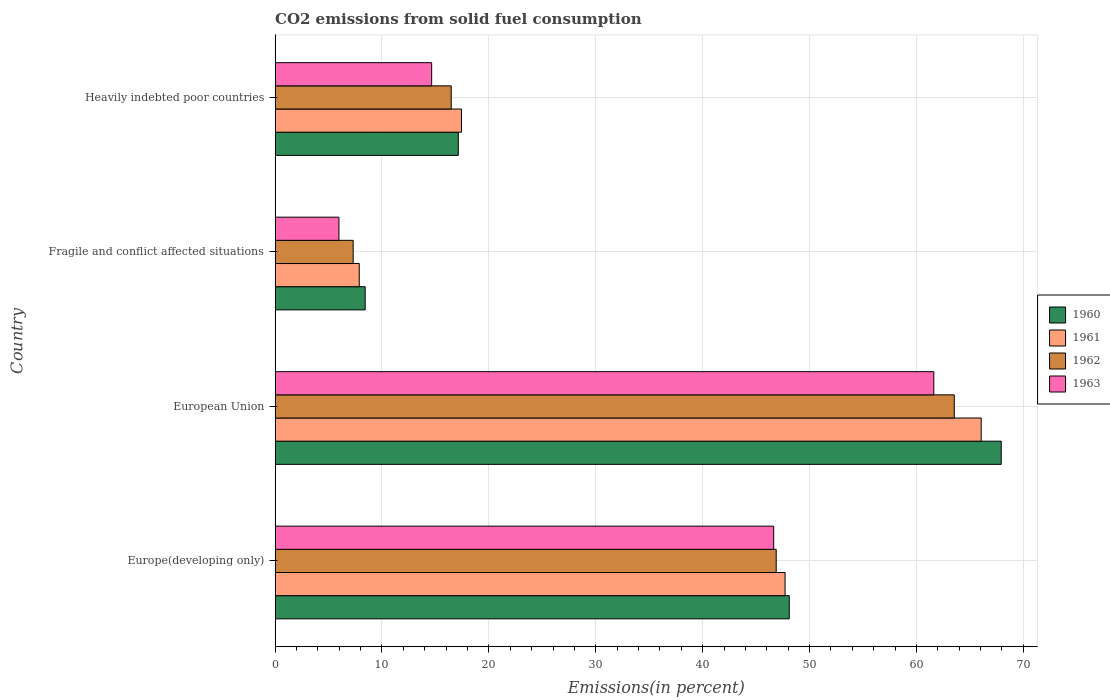How many different coloured bars are there?
Provide a short and direct response. 4. Are the number of bars per tick equal to the number of legend labels?
Keep it short and to the point. Yes. How many bars are there on the 2nd tick from the top?
Your response must be concise. 4. How many bars are there on the 3rd tick from the bottom?
Offer a terse response. 4. What is the label of the 4th group of bars from the top?
Make the answer very short. Europe(developing only). In how many cases, is the number of bars for a given country not equal to the number of legend labels?
Provide a short and direct response. 0. What is the total CO2 emitted in 1963 in Europe(developing only)?
Keep it short and to the point. 46.64. Across all countries, what is the maximum total CO2 emitted in 1960?
Offer a very short reply. 67.93. Across all countries, what is the minimum total CO2 emitted in 1962?
Offer a terse response. 7.31. In which country was the total CO2 emitted in 1962 minimum?
Keep it short and to the point. Fragile and conflict affected situations. What is the total total CO2 emitted in 1960 in the graph?
Offer a very short reply. 141.6. What is the difference between the total CO2 emitted in 1963 in Europe(developing only) and that in Fragile and conflict affected situations?
Offer a terse response. 40.67. What is the difference between the total CO2 emitted in 1962 in Heavily indebted poor countries and the total CO2 emitted in 1961 in European Union?
Offer a very short reply. -49.58. What is the average total CO2 emitted in 1960 per country?
Offer a terse response. 35.4. What is the difference between the total CO2 emitted in 1963 and total CO2 emitted in 1960 in Europe(developing only)?
Ensure brevity in your answer.  -1.46. What is the ratio of the total CO2 emitted in 1960 in Europe(developing only) to that in Fragile and conflict affected situations?
Give a very brief answer. 5.71. Is the difference between the total CO2 emitted in 1963 in Fragile and conflict affected situations and Heavily indebted poor countries greater than the difference between the total CO2 emitted in 1960 in Fragile and conflict affected situations and Heavily indebted poor countries?
Your answer should be compact. Yes. What is the difference between the highest and the second highest total CO2 emitted in 1962?
Offer a very short reply. 16.66. What is the difference between the highest and the lowest total CO2 emitted in 1961?
Keep it short and to the point. 58.18. In how many countries, is the total CO2 emitted in 1961 greater than the average total CO2 emitted in 1961 taken over all countries?
Offer a very short reply. 2. Is the sum of the total CO2 emitted in 1963 in European Union and Heavily indebted poor countries greater than the maximum total CO2 emitted in 1961 across all countries?
Your response must be concise. Yes. Is it the case that in every country, the sum of the total CO2 emitted in 1963 and total CO2 emitted in 1962 is greater than the sum of total CO2 emitted in 1960 and total CO2 emitted in 1961?
Your answer should be very brief. No. What does the 3rd bar from the top in Heavily indebted poor countries represents?
Keep it short and to the point. 1961. What does the 1st bar from the bottom in European Union represents?
Your response must be concise. 1960. How many bars are there?
Ensure brevity in your answer.  16. Are all the bars in the graph horizontal?
Make the answer very short. Yes. What is the difference between two consecutive major ticks on the X-axis?
Keep it short and to the point. 10. Where does the legend appear in the graph?
Keep it short and to the point. Center right. How are the legend labels stacked?
Ensure brevity in your answer.  Vertical. What is the title of the graph?
Your answer should be very brief. CO2 emissions from solid fuel consumption. Does "1963" appear as one of the legend labels in the graph?
Your response must be concise. Yes. What is the label or title of the X-axis?
Your answer should be compact. Emissions(in percent). What is the Emissions(in percent) in 1960 in Europe(developing only)?
Your answer should be compact. 48.1. What is the Emissions(in percent) of 1961 in Europe(developing only)?
Offer a terse response. 47.71. What is the Emissions(in percent) in 1962 in Europe(developing only)?
Provide a short and direct response. 46.88. What is the Emissions(in percent) in 1963 in Europe(developing only)?
Your response must be concise. 46.64. What is the Emissions(in percent) in 1960 in European Union?
Offer a terse response. 67.93. What is the Emissions(in percent) of 1961 in European Union?
Offer a very short reply. 66.06. What is the Emissions(in percent) of 1962 in European Union?
Keep it short and to the point. 63.54. What is the Emissions(in percent) of 1963 in European Union?
Your response must be concise. 61.62. What is the Emissions(in percent) in 1960 in Fragile and conflict affected situations?
Offer a very short reply. 8.43. What is the Emissions(in percent) of 1961 in Fragile and conflict affected situations?
Keep it short and to the point. 7.87. What is the Emissions(in percent) of 1962 in Fragile and conflict affected situations?
Offer a terse response. 7.31. What is the Emissions(in percent) in 1963 in Fragile and conflict affected situations?
Keep it short and to the point. 5.97. What is the Emissions(in percent) in 1960 in Heavily indebted poor countries?
Provide a succinct answer. 17.14. What is the Emissions(in percent) in 1961 in Heavily indebted poor countries?
Keep it short and to the point. 17.43. What is the Emissions(in percent) of 1962 in Heavily indebted poor countries?
Offer a very short reply. 16.48. What is the Emissions(in percent) in 1963 in Heavily indebted poor countries?
Your answer should be very brief. 14.65. Across all countries, what is the maximum Emissions(in percent) of 1960?
Offer a very short reply. 67.93. Across all countries, what is the maximum Emissions(in percent) of 1961?
Your answer should be very brief. 66.06. Across all countries, what is the maximum Emissions(in percent) in 1962?
Offer a very short reply. 63.54. Across all countries, what is the maximum Emissions(in percent) of 1963?
Keep it short and to the point. 61.62. Across all countries, what is the minimum Emissions(in percent) in 1960?
Make the answer very short. 8.43. Across all countries, what is the minimum Emissions(in percent) in 1961?
Offer a terse response. 7.87. Across all countries, what is the minimum Emissions(in percent) in 1962?
Make the answer very short. 7.31. Across all countries, what is the minimum Emissions(in percent) of 1963?
Your response must be concise. 5.97. What is the total Emissions(in percent) of 1960 in the graph?
Your response must be concise. 141.6. What is the total Emissions(in percent) of 1961 in the graph?
Give a very brief answer. 139.07. What is the total Emissions(in percent) of 1962 in the graph?
Keep it short and to the point. 134.2. What is the total Emissions(in percent) of 1963 in the graph?
Your answer should be compact. 128.88. What is the difference between the Emissions(in percent) in 1960 in Europe(developing only) and that in European Union?
Your response must be concise. -19.83. What is the difference between the Emissions(in percent) in 1961 in Europe(developing only) and that in European Union?
Offer a very short reply. -18.35. What is the difference between the Emissions(in percent) in 1962 in Europe(developing only) and that in European Union?
Offer a terse response. -16.66. What is the difference between the Emissions(in percent) of 1963 in Europe(developing only) and that in European Union?
Offer a very short reply. -14.98. What is the difference between the Emissions(in percent) of 1960 in Europe(developing only) and that in Fragile and conflict affected situations?
Your response must be concise. 39.67. What is the difference between the Emissions(in percent) in 1961 in Europe(developing only) and that in Fragile and conflict affected situations?
Offer a terse response. 39.83. What is the difference between the Emissions(in percent) in 1962 in Europe(developing only) and that in Fragile and conflict affected situations?
Provide a succinct answer. 39.57. What is the difference between the Emissions(in percent) of 1963 in Europe(developing only) and that in Fragile and conflict affected situations?
Ensure brevity in your answer.  40.67. What is the difference between the Emissions(in percent) in 1960 in Europe(developing only) and that in Heavily indebted poor countries?
Give a very brief answer. 30.96. What is the difference between the Emissions(in percent) in 1961 in Europe(developing only) and that in Heavily indebted poor countries?
Offer a terse response. 30.27. What is the difference between the Emissions(in percent) in 1962 in Europe(developing only) and that in Heavily indebted poor countries?
Give a very brief answer. 30.4. What is the difference between the Emissions(in percent) of 1963 in Europe(developing only) and that in Heavily indebted poor countries?
Your answer should be very brief. 32. What is the difference between the Emissions(in percent) of 1960 in European Union and that in Fragile and conflict affected situations?
Your answer should be compact. 59.5. What is the difference between the Emissions(in percent) in 1961 in European Union and that in Fragile and conflict affected situations?
Provide a succinct answer. 58.18. What is the difference between the Emissions(in percent) in 1962 in European Union and that in Fragile and conflict affected situations?
Make the answer very short. 56.23. What is the difference between the Emissions(in percent) in 1963 in European Union and that in Fragile and conflict affected situations?
Provide a short and direct response. 55.65. What is the difference between the Emissions(in percent) of 1960 in European Union and that in Heavily indebted poor countries?
Keep it short and to the point. 50.79. What is the difference between the Emissions(in percent) in 1961 in European Union and that in Heavily indebted poor countries?
Provide a succinct answer. 48.62. What is the difference between the Emissions(in percent) in 1962 in European Union and that in Heavily indebted poor countries?
Offer a very short reply. 47.06. What is the difference between the Emissions(in percent) in 1963 in European Union and that in Heavily indebted poor countries?
Make the answer very short. 46.98. What is the difference between the Emissions(in percent) in 1960 in Fragile and conflict affected situations and that in Heavily indebted poor countries?
Give a very brief answer. -8.71. What is the difference between the Emissions(in percent) of 1961 in Fragile and conflict affected situations and that in Heavily indebted poor countries?
Ensure brevity in your answer.  -9.56. What is the difference between the Emissions(in percent) in 1962 in Fragile and conflict affected situations and that in Heavily indebted poor countries?
Make the answer very short. -9.17. What is the difference between the Emissions(in percent) in 1963 in Fragile and conflict affected situations and that in Heavily indebted poor countries?
Your response must be concise. -8.67. What is the difference between the Emissions(in percent) of 1960 in Europe(developing only) and the Emissions(in percent) of 1961 in European Union?
Offer a terse response. -17.95. What is the difference between the Emissions(in percent) in 1960 in Europe(developing only) and the Emissions(in percent) in 1962 in European Union?
Provide a short and direct response. -15.44. What is the difference between the Emissions(in percent) in 1960 in Europe(developing only) and the Emissions(in percent) in 1963 in European Union?
Offer a terse response. -13.52. What is the difference between the Emissions(in percent) of 1961 in Europe(developing only) and the Emissions(in percent) of 1962 in European Union?
Offer a terse response. -15.83. What is the difference between the Emissions(in percent) of 1961 in Europe(developing only) and the Emissions(in percent) of 1963 in European Union?
Ensure brevity in your answer.  -13.91. What is the difference between the Emissions(in percent) in 1962 in Europe(developing only) and the Emissions(in percent) in 1963 in European Union?
Offer a very short reply. -14.74. What is the difference between the Emissions(in percent) in 1960 in Europe(developing only) and the Emissions(in percent) in 1961 in Fragile and conflict affected situations?
Give a very brief answer. 40.23. What is the difference between the Emissions(in percent) of 1960 in Europe(developing only) and the Emissions(in percent) of 1962 in Fragile and conflict affected situations?
Your answer should be very brief. 40.8. What is the difference between the Emissions(in percent) of 1960 in Europe(developing only) and the Emissions(in percent) of 1963 in Fragile and conflict affected situations?
Your answer should be very brief. 42.13. What is the difference between the Emissions(in percent) in 1961 in Europe(developing only) and the Emissions(in percent) in 1962 in Fragile and conflict affected situations?
Give a very brief answer. 40.4. What is the difference between the Emissions(in percent) of 1961 in Europe(developing only) and the Emissions(in percent) of 1963 in Fragile and conflict affected situations?
Provide a short and direct response. 41.73. What is the difference between the Emissions(in percent) in 1962 in Europe(developing only) and the Emissions(in percent) in 1963 in Fragile and conflict affected situations?
Your answer should be compact. 40.91. What is the difference between the Emissions(in percent) in 1960 in Europe(developing only) and the Emissions(in percent) in 1961 in Heavily indebted poor countries?
Your response must be concise. 30.67. What is the difference between the Emissions(in percent) of 1960 in Europe(developing only) and the Emissions(in percent) of 1962 in Heavily indebted poor countries?
Offer a terse response. 31.63. What is the difference between the Emissions(in percent) of 1960 in Europe(developing only) and the Emissions(in percent) of 1963 in Heavily indebted poor countries?
Offer a very short reply. 33.46. What is the difference between the Emissions(in percent) in 1961 in Europe(developing only) and the Emissions(in percent) in 1962 in Heavily indebted poor countries?
Offer a terse response. 31.23. What is the difference between the Emissions(in percent) in 1961 in Europe(developing only) and the Emissions(in percent) in 1963 in Heavily indebted poor countries?
Keep it short and to the point. 33.06. What is the difference between the Emissions(in percent) in 1962 in Europe(developing only) and the Emissions(in percent) in 1963 in Heavily indebted poor countries?
Offer a terse response. 32.23. What is the difference between the Emissions(in percent) of 1960 in European Union and the Emissions(in percent) of 1961 in Fragile and conflict affected situations?
Keep it short and to the point. 60.06. What is the difference between the Emissions(in percent) in 1960 in European Union and the Emissions(in percent) in 1962 in Fragile and conflict affected situations?
Offer a very short reply. 60.63. What is the difference between the Emissions(in percent) of 1960 in European Union and the Emissions(in percent) of 1963 in Fragile and conflict affected situations?
Your response must be concise. 61.96. What is the difference between the Emissions(in percent) in 1961 in European Union and the Emissions(in percent) in 1962 in Fragile and conflict affected situations?
Your response must be concise. 58.75. What is the difference between the Emissions(in percent) in 1961 in European Union and the Emissions(in percent) in 1963 in Fragile and conflict affected situations?
Make the answer very short. 60.08. What is the difference between the Emissions(in percent) of 1962 in European Union and the Emissions(in percent) of 1963 in Fragile and conflict affected situations?
Make the answer very short. 57.57. What is the difference between the Emissions(in percent) of 1960 in European Union and the Emissions(in percent) of 1961 in Heavily indebted poor countries?
Provide a succinct answer. 50.5. What is the difference between the Emissions(in percent) of 1960 in European Union and the Emissions(in percent) of 1962 in Heavily indebted poor countries?
Make the answer very short. 51.45. What is the difference between the Emissions(in percent) in 1960 in European Union and the Emissions(in percent) in 1963 in Heavily indebted poor countries?
Provide a short and direct response. 53.28. What is the difference between the Emissions(in percent) in 1961 in European Union and the Emissions(in percent) in 1962 in Heavily indebted poor countries?
Give a very brief answer. 49.58. What is the difference between the Emissions(in percent) in 1961 in European Union and the Emissions(in percent) in 1963 in Heavily indebted poor countries?
Your answer should be very brief. 51.41. What is the difference between the Emissions(in percent) of 1962 in European Union and the Emissions(in percent) of 1963 in Heavily indebted poor countries?
Your response must be concise. 48.89. What is the difference between the Emissions(in percent) of 1960 in Fragile and conflict affected situations and the Emissions(in percent) of 1961 in Heavily indebted poor countries?
Your answer should be compact. -9.01. What is the difference between the Emissions(in percent) of 1960 in Fragile and conflict affected situations and the Emissions(in percent) of 1962 in Heavily indebted poor countries?
Keep it short and to the point. -8.05. What is the difference between the Emissions(in percent) of 1960 in Fragile and conflict affected situations and the Emissions(in percent) of 1963 in Heavily indebted poor countries?
Your answer should be compact. -6.22. What is the difference between the Emissions(in percent) of 1961 in Fragile and conflict affected situations and the Emissions(in percent) of 1962 in Heavily indebted poor countries?
Ensure brevity in your answer.  -8.6. What is the difference between the Emissions(in percent) in 1961 in Fragile and conflict affected situations and the Emissions(in percent) in 1963 in Heavily indebted poor countries?
Give a very brief answer. -6.77. What is the difference between the Emissions(in percent) in 1962 in Fragile and conflict affected situations and the Emissions(in percent) in 1963 in Heavily indebted poor countries?
Offer a very short reply. -7.34. What is the average Emissions(in percent) of 1960 per country?
Ensure brevity in your answer.  35.4. What is the average Emissions(in percent) of 1961 per country?
Provide a short and direct response. 34.77. What is the average Emissions(in percent) in 1962 per country?
Make the answer very short. 33.55. What is the average Emissions(in percent) of 1963 per country?
Your response must be concise. 32.22. What is the difference between the Emissions(in percent) in 1960 and Emissions(in percent) in 1961 in Europe(developing only)?
Provide a succinct answer. 0.4. What is the difference between the Emissions(in percent) in 1960 and Emissions(in percent) in 1962 in Europe(developing only)?
Give a very brief answer. 1.22. What is the difference between the Emissions(in percent) of 1960 and Emissions(in percent) of 1963 in Europe(developing only)?
Provide a short and direct response. 1.46. What is the difference between the Emissions(in percent) of 1961 and Emissions(in percent) of 1962 in Europe(developing only)?
Provide a short and direct response. 0.83. What is the difference between the Emissions(in percent) in 1961 and Emissions(in percent) in 1963 in Europe(developing only)?
Provide a short and direct response. 1.07. What is the difference between the Emissions(in percent) of 1962 and Emissions(in percent) of 1963 in Europe(developing only)?
Provide a short and direct response. 0.24. What is the difference between the Emissions(in percent) in 1960 and Emissions(in percent) in 1961 in European Union?
Ensure brevity in your answer.  1.88. What is the difference between the Emissions(in percent) of 1960 and Emissions(in percent) of 1962 in European Union?
Provide a short and direct response. 4.39. What is the difference between the Emissions(in percent) in 1960 and Emissions(in percent) in 1963 in European Union?
Provide a short and direct response. 6.31. What is the difference between the Emissions(in percent) in 1961 and Emissions(in percent) in 1962 in European Union?
Your answer should be very brief. 2.52. What is the difference between the Emissions(in percent) of 1961 and Emissions(in percent) of 1963 in European Union?
Your answer should be compact. 4.43. What is the difference between the Emissions(in percent) of 1962 and Emissions(in percent) of 1963 in European Union?
Make the answer very short. 1.92. What is the difference between the Emissions(in percent) in 1960 and Emissions(in percent) in 1961 in Fragile and conflict affected situations?
Your answer should be very brief. 0.56. What is the difference between the Emissions(in percent) of 1960 and Emissions(in percent) of 1962 in Fragile and conflict affected situations?
Make the answer very short. 1.12. What is the difference between the Emissions(in percent) in 1960 and Emissions(in percent) in 1963 in Fragile and conflict affected situations?
Make the answer very short. 2.46. What is the difference between the Emissions(in percent) in 1961 and Emissions(in percent) in 1962 in Fragile and conflict affected situations?
Provide a succinct answer. 0.57. What is the difference between the Emissions(in percent) of 1961 and Emissions(in percent) of 1963 in Fragile and conflict affected situations?
Make the answer very short. 1.9. What is the difference between the Emissions(in percent) in 1962 and Emissions(in percent) in 1963 in Fragile and conflict affected situations?
Ensure brevity in your answer.  1.33. What is the difference between the Emissions(in percent) in 1960 and Emissions(in percent) in 1961 in Heavily indebted poor countries?
Provide a short and direct response. -0.29. What is the difference between the Emissions(in percent) of 1960 and Emissions(in percent) of 1962 in Heavily indebted poor countries?
Make the answer very short. 0.66. What is the difference between the Emissions(in percent) of 1960 and Emissions(in percent) of 1963 in Heavily indebted poor countries?
Your response must be concise. 2.49. What is the difference between the Emissions(in percent) of 1961 and Emissions(in percent) of 1962 in Heavily indebted poor countries?
Provide a short and direct response. 0.96. What is the difference between the Emissions(in percent) of 1961 and Emissions(in percent) of 1963 in Heavily indebted poor countries?
Make the answer very short. 2.79. What is the difference between the Emissions(in percent) of 1962 and Emissions(in percent) of 1963 in Heavily indebted poor countries?
Ensure brevity in your answer.  1.83. What is the ratio of the Emissions(in percent) of 1960 in Europe(developing only) to that in European Union?
Ensure brevity in your answer.  0.71. What is the ratio of the Emissions(in percent) in 1961 in Europe(developing only) to that in European Union?
Your answer should be very brief. 0.72. What is the ratio of the Emissions(in percent) in 1962 in Europe(developing only) to that in European Union?
Make the answer very short. 0.74. What is the ratio of the Emissions(in percent) in 1963 in Europe(developing only) to that in European Union?
Provide a short and direct response. 0.76. What is the ratio of the Emissions(in percent) of 1960 in Europe(developing only) to that in Fragile and conflict affected situations?
Give a very brief answer. 5.71. What is the ratio of the Emissions(in percent) of 1961 in Europe(developing only) to that in Fragile and conflict affected situations?
Your response must be concise. 6.06. What is the ratio of the Emissions(in percent) in 1962 in Europe(developing only) to that in Fragile and conflict affected situations?
Your response must be concise. 6.42. What is the ratio of the Emissions(in percent) of 1963 in Europe(developing only) to that in Fragile and conflict affected situations?
Keep it short and to the point. 7.81. What is the ratio of the Emissions(in percent) in 1960 in Europe(developing only) to that in Heavily indebted poor countries?
Keep it short and to the point. 2.81. What is the ratio of the Emissions(in percent) in 1961 in Europe(developing only) to that in Heavily indebted poor countries?
Make the answer very short. 2.74. What is the ratio of the Emissions(in percent) of 1962 in Europe(developing only) to that in Heavily indebted poor countries?
Provide a short and direct response. 2.85. What is the ratio of the Emissions(in percent) in 1963 in Europe(developing only) to that in Heavily indebted poor countries?
Offer a terse response. 3.18. What is the ratio of the Emissions(in percent) in 1960 in European Union to that in Fragile and conflict affected situations?
Offer a very short reply. 8.06. What is the ratio of the Emissions(in percent) of 1961 in European Union to that in Fragile and conflict affected situations?
Offer a very short reply. 8.39. What is the ratio of the Emissions(in percent) of 1962 in European Union to that in Fragile and conflict affected situations?
Ensure brevity in your answer.  8.7. What is the ratio of the Emissions(in percent) in 1963 in European Union to that in Fragile and conflict affected situations?
Your answer should be compact. 10.32. What is the ratio of the Emissions(in percent) in 1960 in European Union to that in Heavily indebted poor countries?
Keep it short and to the point. 3.96. What is the ratio of the Emissions(in percent) of 1961 in European Union to that in Heavily indebted poor countries?
Provide a short and direct response. 3.79. What is the ratio of the Emissions(in percent) of 1962 in European Union to that in Heavily indebted poor countries?
Make the answer very short. 3.86. What is the ratio of the Emissions(in percent) in 1963 in European Union to that in Heavily indebted poor countries?
Offer a terse response. 4.21. What is the ratio of the Emissions(in percent) of 1960 in Fragile and conflict affected situations to that in Heavily indebted poor countries?
Your answer should be compact. 0.49. What is the ratio of the Emissions(in percent) in 1961 in Fragile and conflict affected situations to that in Heavily indebted poor countries?
Your response must be concise. 0.45. What is the ratio of the Emissions(in percent) of 1962 in Fragile and conflict affected situations to that in Heavily indebted poor countries?
Give a very brief answer. 0.44. What is the ratio of the Emissions(in percent) of 1963 in Fragile and conflict affected situations to that in Heavily indebted poor countries?
Your response must be concise. 0.41. What is the difference between the highest and the second highest Emissions(in percent) in 1960?
Provide a succinct answer. 19.83. What is the difference between the highest and the second highest Emissions(in percent) of 1961?
Provide a short and direct response. 18.35. What is the difference between the highest and the second highest Emissions(in percent) of 1962?
Your response must be concise. 16.66. What is the difference between the highest and the second highest Emissions(in percent) in 1963?
Your response must be concise. 14.98. What is the difference between the highest and the lowest Emissions(in percent) of 1960?
Offer a very short reply. 59.5. What is the difference between the highest and the lowest Emissions(in percent) in 1961?
Keep it short and to the point. 58.18. What is the difference between the highest and the lowest Emissions(in percent) of 1962?
Offer a terse response. 56.23. What is the difference between the highest and the lowest Emissions(in percent) of 1963?
Offer a terse response. 55.65. 